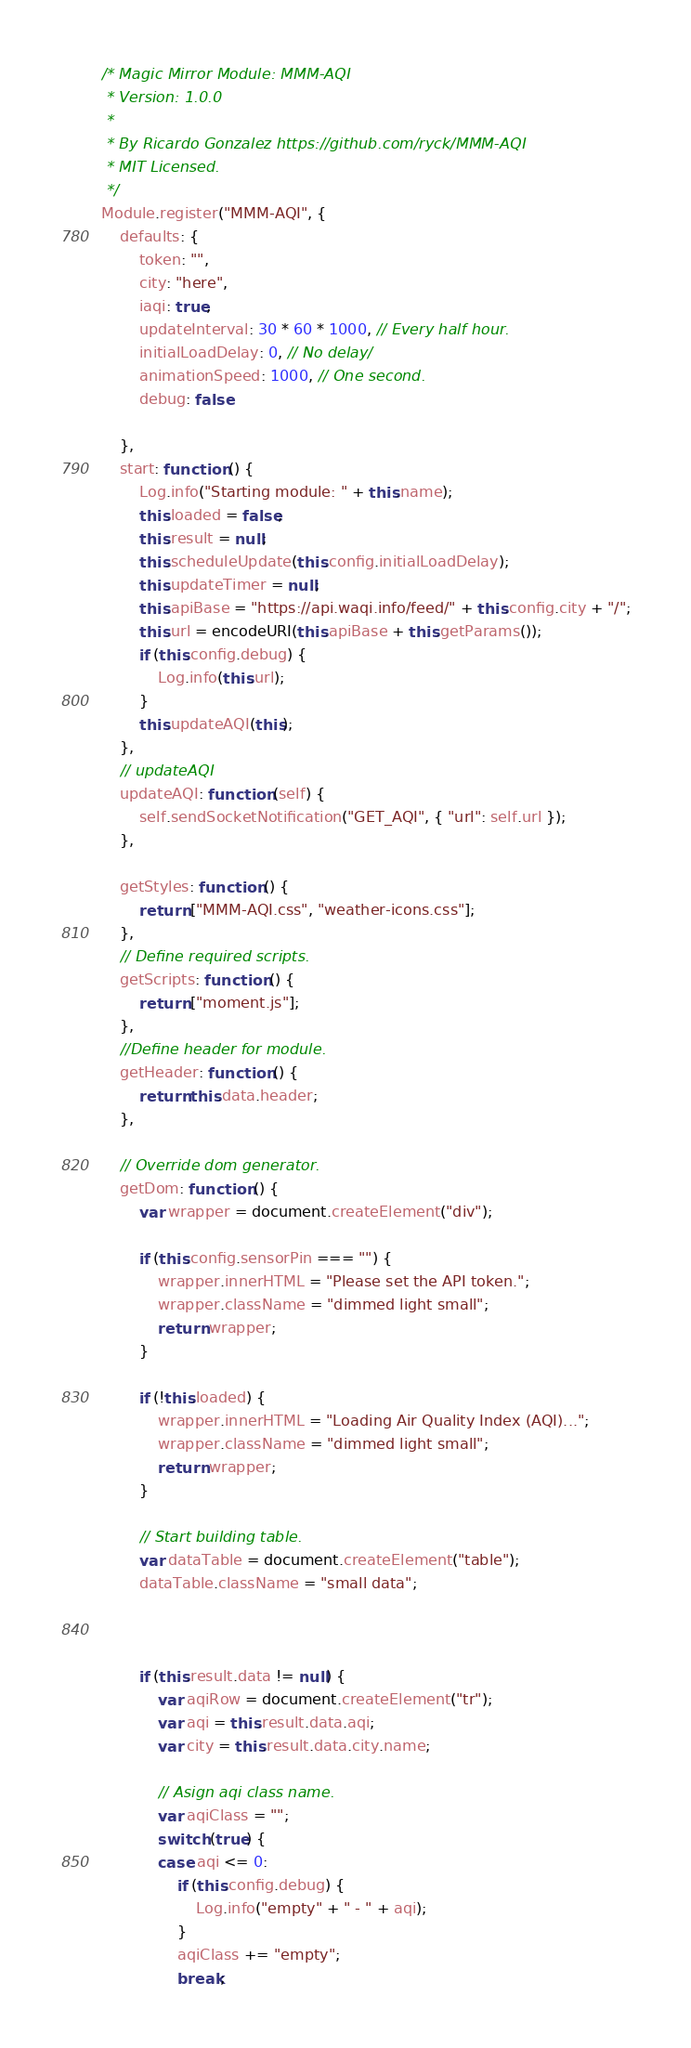<code> <loc_0><loc_0><loc_500><loc_500><_JavaScript_>/* Magic Mirror Module: MMM-AQI
 * Version: 1.0.0
 *
 * By Ricardo Gonzalez https://github.com/ryck/MMM-AQI
 * MIT Licensed.
 */
Module.register("MMM-AQI", {
	defaults: {
		token: "",
		city: "here",
		iaqi: true,
		updateInterval: 30 * 60 * 1000, // Every half hour.
		initialLoadDelay: 0, // No delay/
		animationSpeed: 1000, // One second.
		debug: false

	},
	start: function () {
		Log.info("Starting module: " + this.name);
		this.loaded = false;
		this.result = null;
		this.scheduleUpdate(this.config.initialLoadDelay);
		this.updateTimer = null;
		this.apiBase = "https://api.waqi.info/feed/" + this.config.city + "/";
		this.url = encodeURI(this.apiBase + this.getParams());
		if (this.config.debug) {
			Log.info(this.url);
		}
		this.updateAQI(this);
	},
	// updateAQI
	updateAQI: function (self) {
		self.sendSocketNotification("GET_AQI", { "url": self.url });
	},

	getStyles: function () {
		return ["MMM-AQI.css", "weather-icons.css"];
	},
	// Define required scripts.
	getScripts: function () {
		return ["moment.js"];
	},
	//Define header for module.
	getHeader: function () {
		return this.data.header;
	},

	// Override dom generator.
	getDom: function () {
		var wrapper = document.createElement("div");

		if (this.config.sensorPin === "") {
			wrapper.innerHTML = "Please set the API token.";
			wrapper.className = "dimmed light small";
			return wrapper;
		}

		if (!this.loaded) {
			wrapper.innerHTML = "Loading Air Quality Index (AQI)...";
			wrapper.className = "dimmed light small";
			return wrapper;
		}

		// Start building table.
		var dataTable = document.createElement("table");
		dataTable.className = "small data";



		if (this.result.data != null) {
			var aqiRow = document.createElement("tr");
			var aqi = this.result.data.aqi;
			var city = this.result.data.city.name;

			// Asign aqi class name.
			var aqiClass = "";
			switch (true) {
			case aqi <= 0:
				if (this.config.debug) {
					Log.info("empty" + " - " + aqi);
				}
				aqiClass += "empty";
				break;</code> 